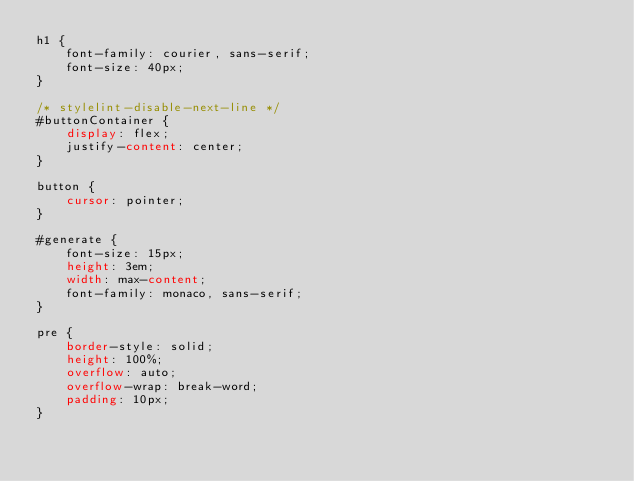<code> <loc_0><loc_0><loc_500><loc_500><_CSS_>h1 {
    font-family: courier, sans-serif;
    font-size: 40px;
}

/* stylelint-disable-next-line */
#buttonContainer {
    display: flex;
    justify-content: center;
}

button {
    cursor: pointer;
}

#generate {
    font-size: 15px;
    height: 3em;
    width: max-content;
    font-family: monaco, sans-serif;
}

pre {
    border-style: solid;
    height: 100%;
    overflow: auto;
    overflow-wrap: break-word;
    padding: 10px;
}
</code> 